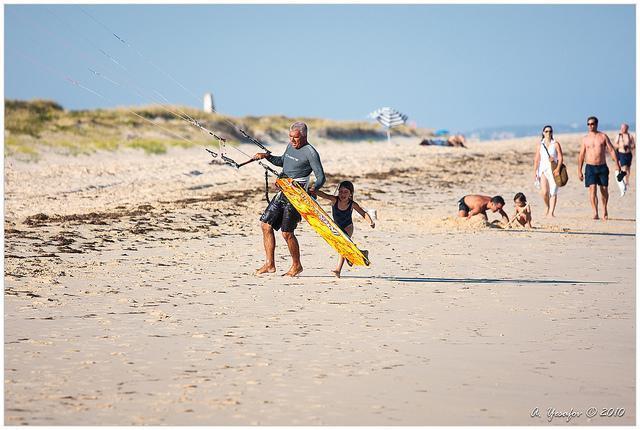How many dogs are visible?
Give a very brief answer. 0. How many people are there?
Give a very brief answer. 2. How many bottles are missing?
Give a very brief answer. 0. 